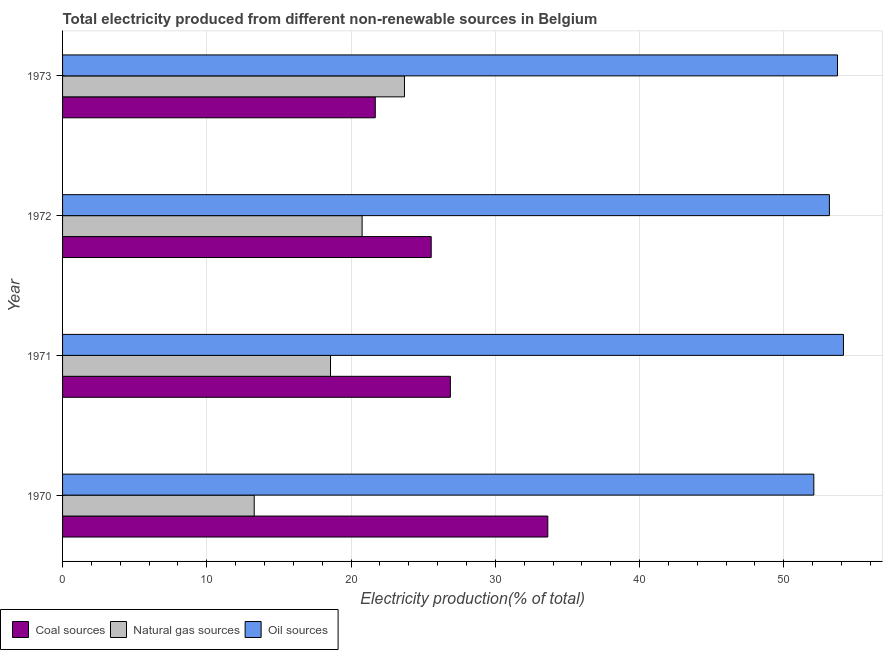How many different coloured bars are there?
Give a very brief answer. 3. How many bars are there on the 4th tick from the bottom?
Give a very brief answer. 3. What is the label of the 2nd group of bars from the top?
Make the answer very short. 1972. In how many cases, is the number of bars for a given year not equal to the number of legend labels?
Keep it short and to the point. 0. What is the percentage of electricity produced by oil sources in 1970?
Keep it short and to the point. 52.08. Across all years, what is the maximum percentage of electricity produced by coal?
Keep it short and to the point. 33.64. Across all years, what is the minimum percentage of electricity produced by oil sources?
Provide a succinct answer. 52.08. In which year was the percentage of electricity produced by coal minimum?
Provide a succinct answer. 1973. What is the total percentage of electricity produced by oil sources in the graph?
Your answer should be very brief. 213.1. What is the difference between the percentage of electricity produced by coal in 1972 and the percentage of electricity produced by oil sources in 1971?
Offer a very short reply. -28.58. What is the average percentage of electricity produced by natural gas per year?
Offer a very short reply. 19.08. In the year 1973, what is the difference between the percentage of electricity produced by oil sources and percentage of electricity produced by natural gas?
Ensure brevity in your answer.  30.02. In how many years, is the percentage of electricity produced by coal greater than 24 %?
Make the answer very short. 3. What is the ratio of the percentage of electricity produced by oil sources in 1972 to that in 1973?
Make the answer very short. 0.99. Is the difference between the percentage of electricity produced by oil sources in 1971 and 1973 greater than the difference between the percentage of electricity produced by natural gas in 1971 and 1973?
Offer a very short reply. Yes. What is the difference between the highest and the second highest percentage of electricity produced by oil sources?
Offer a very short reply. 0.41. What is the difference between the highest and the lowest percentage of electricity produced by natural gas?
Make the answer very short. 10.42. In how many years, is the percentage of electricity produced by oil sources greater than the average percentage of electricity produced by oil sources taken over all years?
Ensure brevity in your answer.  2. Is the sum of the percentage of electricity produced by coal in 1972 and 1973 greater than the maximum percentage of electricity produced by oil sources across all years?
Offer a very short reply. No. What does the 2nd bar from the top in 1972 represents?
Make the answer very short. Natural gas sources. What does the 3rd bar from the bottom in 1973 represents?
Your answer should be compact. Oil sources. Is it the case that in every year, the sum of the percentage of electricity produced by coal and percentage of electricity produced by natural gas is greater than the percentage of electricity produced by oil sources?
Offer a terse response. No. How many bars are there?
Keep it short and to the point. 12. Does the graph contain any zero values?
Provide a short and direct response. No. How many legend labels are there?
Offer a terse response. 3. How are the legend labels stacked?
Keep it short and to the point. Horizontal. What is the title of the graph?
Offer a terse response. Total electricity produced from different non-renewable sources in Belgium. Does "Central government" appear as one of the legend labels in the graph?
Give a very brief answer. No. What is the label or title of the X-axis?
Offer a very short reply. Electricity production(% of total). What is the label or title of the Y-axis?
Your answer should be very brief. Year. What is the Electricity production(% of total) in Coal sources in 1970?
Give a very brief answer. 33.64. What is the Electricity production(% of total) in Natural gas sources in 1970?
Provide a succinct answer. 13.29. What is the Electricity production(% of total) of Oil sources in 1970?
Give a very brief answer. 52.08. What is the Electricity production(% of total) in Coal sources in 1971?
Your answer should be compact. 26.89. What is the Electricity production(% of total) in Natural gas sources in 1971?
Your answer should be very brief. 18.58. What is the Electricity production(% of total) of Oil sources in 1971?
Provide a succinct answer. 54.14. What is the Electricity production(% of total) in Coal sources in 1972?
Provide a short and direct response. 25.56. What is the Electricity production(% of total) in Natural gas sources in 1972?
Your answer should be compact. 20.77. What is the Electricity production(% of total) in Oil sources in 1972?
Offer a terse response. 53.16. What is the Electricity production(% of total) in Coal sources in 1973?
Your answer should be very brief. 21.68. What is the Electricity production(% of total) in Natural gas sources in 1973?
Your response must be concise. 23.7. What is the Electricity production(% of total) of Oil sources in 1973?
Give a very brief answer. 53.72. Across all years, what is the maximum Electricity production(% of total) in Coal sources?
Provide a succinct answer. 33.64. Across all years, what is the maximum Electricity production(% of total) of Natural gas sources?
Offer a terse response. 23.7. Across all years, what is the maximum Electricity production(% of total) in Oil sources?
Your response must be concise. 54.14. Across all years, what is the minimum Electricity production(% of total) of Coal sources?
Your answer should be compact. 21.68. Across all years, what is the minimum Electricity production(% of total) in Natural gas sources?
Provide a succinct answer. 13.29. Across all years, what is the minimum Electricity production(% of total) in Oil sources?
Make the answer very short. 52.08. What is the total Electricity production(% of total) of Coal sources in the graph?
Your answer should be very brief. 107.76. What is the total Electricity production(% of total) in Natural gas sources in the graph?
Give a very brief answer. 76.33. What is the total Electricity production(% of total) of Oil sources in the graph?
Keep it short and to the point. 213.1. What is the difference between the Electricity production(% of total) of Coal sources in 1970 and that in 1971?
Offer a terse response. 6.75. What is the difference between the Electricity production(% of total) in Natural gas sources in 1970 and that in 1971?
Keep it short and to the point. -5.29. What is the difference between the Electricity production(% of total) of Oil sources in 1970 and that in 1971?
Provide a succinct answer. -2.05. What is the difference between the Electricity production(% of total) of Coal sources in 1970 and that in 1972?
Keep it short and to the point. 8.08. What is the difference between the Electricity production(% of total) of Natural gas sources in 1970 and that in 1972?
Give a very brief answer. -7.48. What is the difference between the Electricity production(% of total) in Oil sources in 1970 and that in 1972?
Make the answer very short. -1.08. What is the difference between the Electricity production(% of total) of Coal sources in 1970 and that in 1973?
Provide a short and direct response. 11.96. What is the difference between the Electricity production(% of total) of Natural gas sources in 1970 and that in 1973?
Give a very brief answer. -10.42. What is the difference between the Electricity production(% of total) of Oil sources in 1970 and that in 1973?
Keep it short and to the point. -1.64. What is the difference between the Electricity production(% of total) of Coal sources in 1971 and that in 1972?
Provide a succinct answer. 1.33. What is the difference between the Electricity production(% of total) of Natural gas sources in 1971 and that in 1972?
Provide a short and direct response. -2.19. What is the difference between the Electricity production(% of total) in Oil sources in 1971 and that in 1972?
Your response must be concise. 0.97. What is the difference between the Electricity production(% of total) in Coal sources in 1971 and that in 1973?
Keep it short and to the point. 5.21. What is the difference between the Electricity production(% of total) in Natural gas sources in 1971 and that in 1973?
Give a very brief answer. -5.13. What is the difference between the Electricity production(% of total) in Oil sources in 1971 and that in 1973?
Make the answer very short. 0.41. What is the difference between the Electricity production(% of total) in Coal sources in 1972 and that in 1973?
Your answer should be compact. 3.88. What is the difference between the Electricity production(% of total) in Natural gas sources in 1972 and that in 1973?
Your response must be concise. -2.94. What is the difference between the Electricity production(% of total) in Oil sources in 1972 and that in 1973?
Make the answer very short. -0.56. What is the difference between the Electricity production(% of total) of Coal sources in 1970 and the Electricity production(% of total) of Natural gas sources in 1971?
Provide a succinct answer. 15.06. What is the difference between the Electricity production(% of total) in Coal sources in 1970 and the Electricity production(% of total) in Oil sources in 1971?
Your answer should be compact. -20.5. What is the difference between the Electricity production(% of total) in Natural gas sources in 1970 and the Electricity production(% of total) in Oil sources in 1971?
Make the answer very short. -40.85. What is the difference between the Electricity production(% of total) of Coal sources in 1970 and the Electricity production(% of total) of Natural gas sources in 1972?
Your answer should be very brief. 12.87. What is the difference between the Electricity production(% of total) in Coal sources in 1970 and the Electricity production(% of total) in Oil sources in 1972?
Provide a short and direct response. -19.52. What is the difference between the Electricity production(% of total) in Natural gas sources in 1970 and the Electricity production(% of total) in Oil sources in 1972?
Ensure brevity in your answer.  -39.88. What is the difference between the Electricity production(% of total) in Coal sources in 1970 and the Electricity production(% of total) in Natural gas sources in 1973?
Give a very brief answer. 9.94. What is the difference between the Electricity production(% of total) of Coal sources in 1970 and the Electricity production(% of total) of Oil sources in 1973?
Offer a terse response. -20.08. What is the difference between the Electricity production(% of total) in Natural gas sources in 1970 and the Electricity production(% of total) in Oil sources in 1973?
Provide a succinct answer. -40.44. What is the difference between the Electricity production(% of total) in Coal sources in 1971 and the Electricity production(% of total) in Natural gas sources in 1972?
Your answer should be very brief. 6.12. What is the difference between the Electricity production(% of total) of Coal sources in 1971 and the Electricity production(% of total) of Oil sources in 1972?
Your response must be concise. -26.28. What is the difference between the Electricity production(% of total) of Natural gas sources in 1971 and the Electricity production(% of total) of Oil sources in 1972?
Make the answer very short. -34.59. What is the difference between the Electricity production(% of total) in Coal sources in 1971 and the Electricity production(% of total) in Natural gas sources in 1973?
Provide a short and direct response. 3.18. What is the difference between the Electricity production(% of total) in Coal sources in 1971 and the Electricity production(% of total) in Oil sources in 1973?
Offer a very short reply. -26.84. What is the difference between the Electricity production(% of total) of Natural gas sources in 1971 and the Electricity production(% of total) of Oil sources in 1973?
Provide a succinct answer. -35.15. What is the difference between the Electricity production(% of total) of Coal sources in 1972 and the Electricity production(% of total) of Natural gas sources in 1973?
Make the answer very short. 1.85. What is the difference between the Electricity production(% of total) of Coal sources in 1972 and the Electricity production(% of total) of Oil sources in 1973?
Your answer should be compact. -28.17. What is the difference between the Electricity production(% of total) of Natural gas sources in 1972 and the Electricity production(% of total) of Oil sources in 1973?
Your answer should be very brief. -32.96. What is the average Electricity production(% of total) in Coal sources per year?
Offer a terse response. 26.94. What is the average Electricity production(% of total) in Natural gas sources per year?
Make the answer very short. 19.08. What is the average Electricity production(% of total) of Oil sources per year?
Keep it short and to the point. 53.28. In the year 1970, what is the difference between the Electricity production(% of total) of Coal sources and Electricity production(% of total) of Natural gas sources?
Your answer should be compact. 20.36. In the year 1970, what is the difference between the Electricity production(% of total) in Coal sources and Electricity production(% of total) in Oil sources?
Give a very brief answer. -18.44. In the year 1970, what is the difference between the Electricity production(% of total) in Natural gas sources and Electricity production(% of total) in Oil sources?
Offer a very short reply. -38.8. In the year 1971, what is the difference between the Electricity production(% of total) of Coal sources and Electricity production(% of total) of Natural gas sources?
Your answer should be very brief. 8.31. In the year 1971, what is the difference between the Electricity production(% of total) in Coal sources and Electricity production(% of total) in Oil sources?
Provide a succinct answer. -27.25. In the year 1971, what is the difference between the Electricity production(% of total) of Natural gas sources and Electricity production(% of total) of Oil sources?
Your answer should be very brief. -35.56. In the year 1972, what is the difference between the Electricity production(% of total) of Coal sources and Electricity production(% of total) of Natural gas sources?
Keep it short and to the point. 4.79. In the year 1972, what is the difference between the Electricity production(% of total) in Coal sources and Electricity production(% of total) in Oil sources?
Give a very brief answer. -27.61. In the year 1972, what is the difference between the Electricity production(% of total) of Natural gas sources and Electricity production(% of total) of Oil sources?
Provide a short and direct response. -32.4. In the year 1973, what is the difference between the Electricity production(% of total) in Coal sources and Electricity production(% of total) in Natural gas sources?
Keep it short and to the point. -2.02. In the year 1973, what is the difference between the Electricity production(% of total) in Coal sources and Electricity production(% of total) in Oil sources?
Provide a succinct answer. -32.04. In the year 1973, what is the difference between the Electricity production(% of total) in Natural gas sources and Electricity production(% of total) in Oil sources?
Your response must be concise. -30.02. What is the ratio of the Electricity production(% of total) of Coal sources in 1970 to that in 1971?
Offer a terse response. 1.25. What is the ratio of the Electricity production(% of total) of Natural gas sources in 1970 to that in 1971?
Provide a short and direct response. 0.72. What is the ratio of the Electricity production(% of total) of Oil sources in 1970 to that in 1971?
Provide a succinct answer. 0.96. What is the ratio of the Electricity production(% of total) of Coal sources in 1970 to that in 1972?
Make the answer very short. 1.32. What is the ratio of the Electricity production(% of total) of Natural gas sources in 1970 to that in 1972?
Your response must be concise. 0.64. What is the ratio of the Electricity production(% of total) of Oil sources in 1970 to that in 1972?
Offer a very short reply. 0.98. What is the ratio of the Electricity production(% of total) of Coal sources in 1970 to that in 1973?
Your response must be concise. 1.55. What is the ratio of the Electricity production(% of total) in Natural gas sources in 1970 to that in 1973?
Offer a very short reply. 0.56. What is the ratio of the Electricity production(% of total) in Oil sources in 1970 to that in 1973?
Provide a succinct answer. 0.97. What is the ratio of the Electricity production(% of total) in Coal sources in 1971 to that in 1972?
Provide a short and direct response. 1.05. What is the ratio of the Electricity production(% of total) in Natural gas sources in 1971 to that in 1972?
Keep it short and to the point. 0.89. What is the ratio of the Electricity production(% of total) in Oil sources in 1971 to that in 1972?
Make the answer very short. 1.02. What is the ratio of the Electricity production(% of total) of Coal sources in 1971 to that in 1973?
Your response must be concise. 1.24. What is the ratio of the Electricity production(% of total) of Natural gas sources in 1971 to that in 1973?
Provide a short and direct response. 0.78. What is the ratio of the Electricity production(% of total) of Oil sources in 1971 to that in 1973?
Ensure brevity in your answer.  1.01. What is the ratio of the Electricity production(% of total) of Coal sources in 1972 to that in 1973?
Your answer should be very brief. 1.18. What is the ratio of the Electricity production(% of total) of Natural gas sources in 1972 to that in 1973?
Provide a short and direct response. 0.88. What is the difference between the highest and the second highest Electricity production(% of total) in Coal sources?
Your response must be concise. 6.75. What is the difference between the highest and the second highest Electricity production(% of total) of Natural gas sources?
Your answer should be very brief. 2.94. What is the difference between the highest and the second highest Electricity production(% of total) in Oil sources?
Give a very brief answer. 0.41. What is the difference between the highest and the lowest Electricity production(% of total) of Coal sources?
Your response must be concise. 11.96. What is the difference between the highest and the lowest Electricity production(% of total) of Natural gas sources?
Your response must be concise. 10.42. What is the difference between the highest and the lowest Electricity production(% of total) in Oil sources?
Provide a succinct answer. 2.05. 